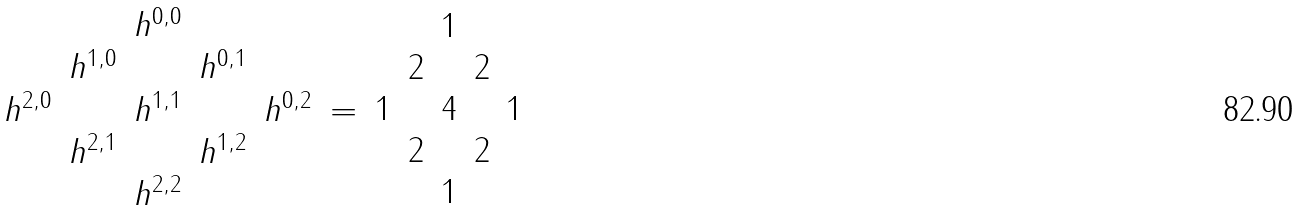Convert formula to latex. <formula><loc_0><loc_0><loc_500><loc_500>\begin{array} { c c c c c } & & h ^ { 0 , 0 } & & \\ & h ^ { 1 , 0 } & & h ^ { 0 , 1 } & \\ h ^ { 2 , 0 } & & h ^ { 1 , 1 } & & h ^ { 0 , 2 } \\ & h ^ { 2 , 1 } & & h ^ { 1 , 2 } & \\ & & h ^ { 2 , 2 } & & \\ \end{array} = \begin{array} { c c c c c } & & 1 & & \\ & 2 & & 2 & \\ 1 & & 4 & & 1 \\ & 2 & & 2 & \\ & & 1 & & \\ \end{array}</formula> 